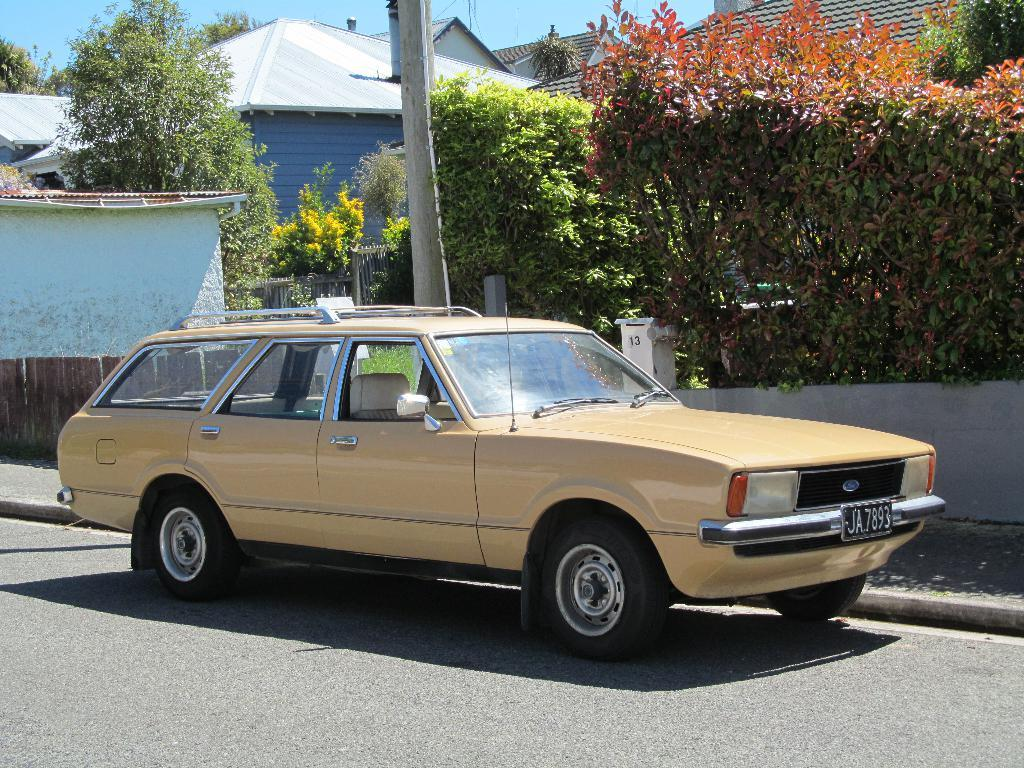What is the main subject of the image? There is a car on the road in the image. What else can be seen in the image besides the car? Plants and buildings are visible in the image. What type of rod is being used to hold the notebook in the image? There is no rod or notebook present in the image. 